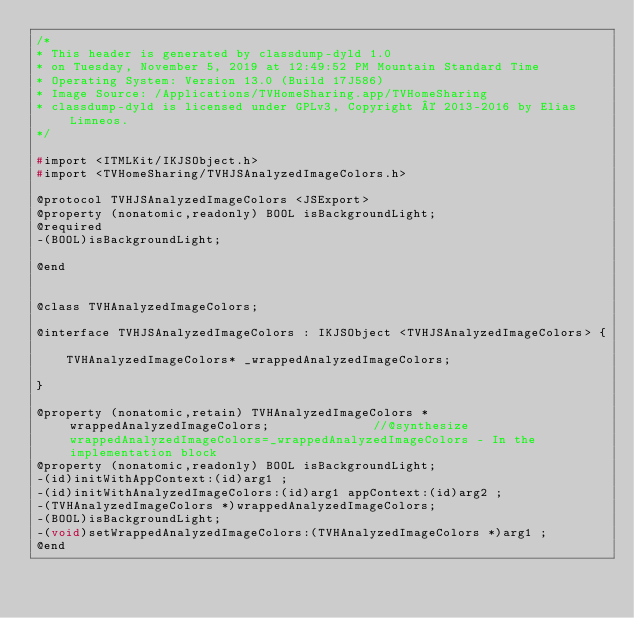Convert code to text. <code><loc_0><loc_0><loc_500><loc_500><_C_>/*
* This header is generated by classdump-dyld 1.0
* on Tuesday, November 5, 2019 at 12:49:52 PM Mountain Standard Time
* Operating System: Version 13.0 (Build 17J586)
* Image Source: /Applications/TVHomeSharing.app/TVHomeSharing
* classdump-dyld is licensed under GPLv3, Copyright © 2013-2016 by Elias Limneos.
*/

#import <ITMLKit/IKJSObject.h>
#import <TVHomeSharing/TVHJSAnalyzedImageColors.h>

@protocol TVHJSAnalyzedImageColors <JSExport>
@property (nonatomic,readonly) BOOL isBackgroundLight; 
@required
-(BOOL)isBackgroundLight;

@end


@class TVHAnalyzedImageColors;

@interface TVHJSAnalyzedImageColors : IKJSObject <TVHJSAnalyzedImageColors> {

	TVHAnalyzedImageColors* _wrappedAnalyzedImageColors;

}

@property (nonatomic,retain) TVHAnalyzedImageColors * wrappedAnalyzedImageColors;              //@synthesize wrappedAnalyzedImageColors=_wrappedAnalyzedImageColors - In the implementation block
@property (nonatomic,readonly) BOOL isBackgroundLight; 
-(id)initWithAppContext:(id)arg1 ;
-(id)initWithAnalyzedImageColors:(id)arg1 appContext:(id)arg2 ;
-(TVHAnalyzedImageColors *)wrappedAnalyzedImageColors;
-(BOOL)isBackgroundLight;
-(void)setWrappedAnalyzedImageColors:(TVHAnalyzedImageColors *)arg1 ;
@end

</code> 